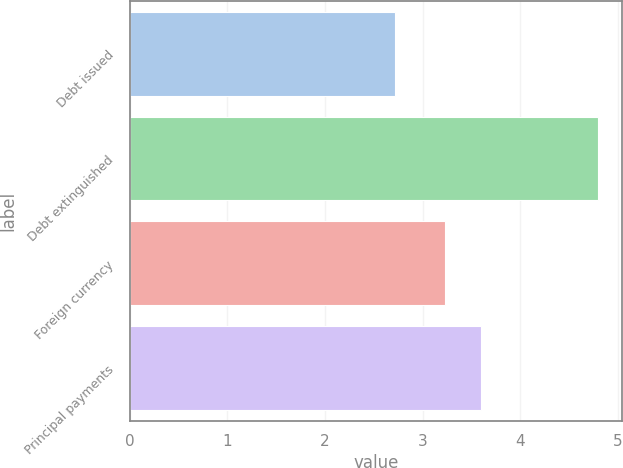Convert chart. <chart><loc_0><loc_0><loc_500><loc_500><bar_chart><fcel>Debt issued<fcel>Debt extinguished<fcel>Foreign currency<fcel>Principal payments<nl><fcel>2.72<fcel>4.8<fcel>3.23<fcel>3.6<nl></chart> 